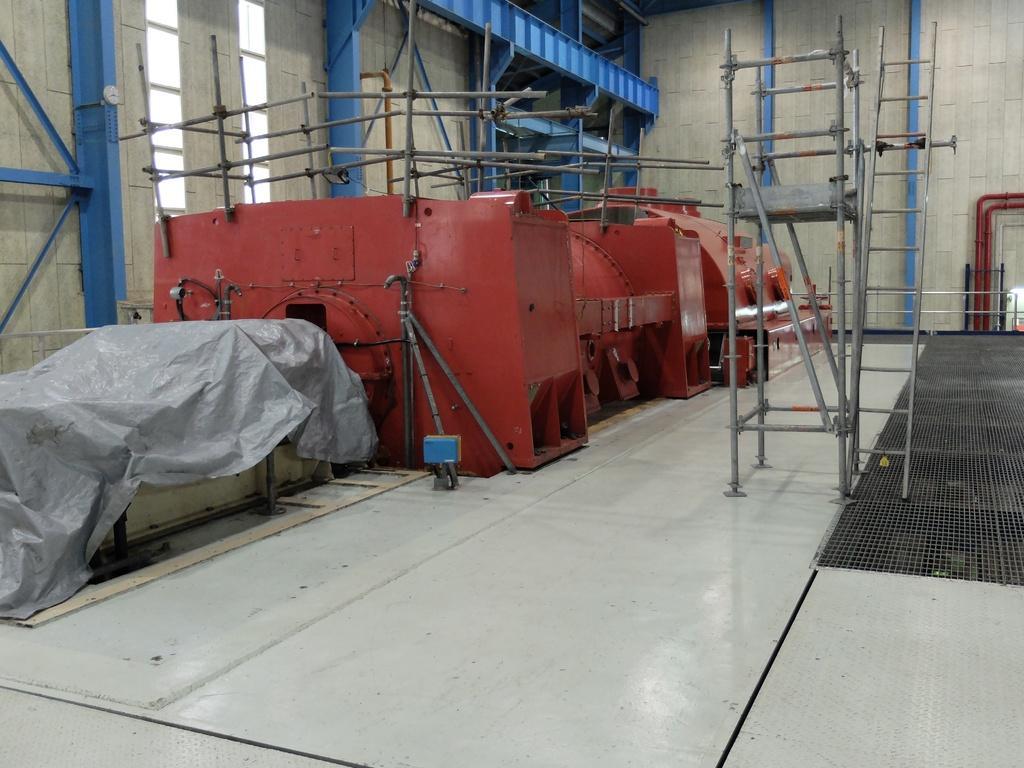Describe this image in one or two sentences. In this picture, we can see the ground with some metallic objects, cover, and we can see the wall with metallic object, entrance, and we can see ladder. 